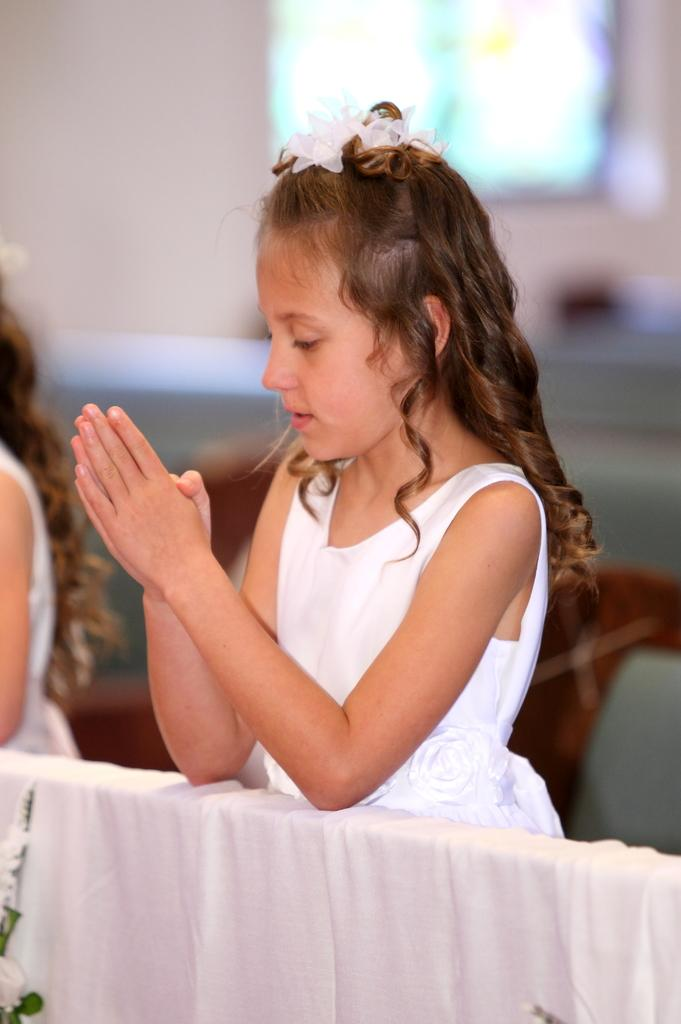Who is the main subject in the image? There is a girl in the image. What is the girl doing in the image? The girl is offering prayer. What is the girl wearing in the image? The girl is wearing a white dress. What other white object can be seen in the image? There is a white cloth in the image. How would you describe the background of the image? The background of the image is blurred. What type of property does the girl own in the image? There is no information about the girl owning any property in the image. How many feet can be seen in the image? There are no feet visible in the image; it only shows the girl offering prayer. 